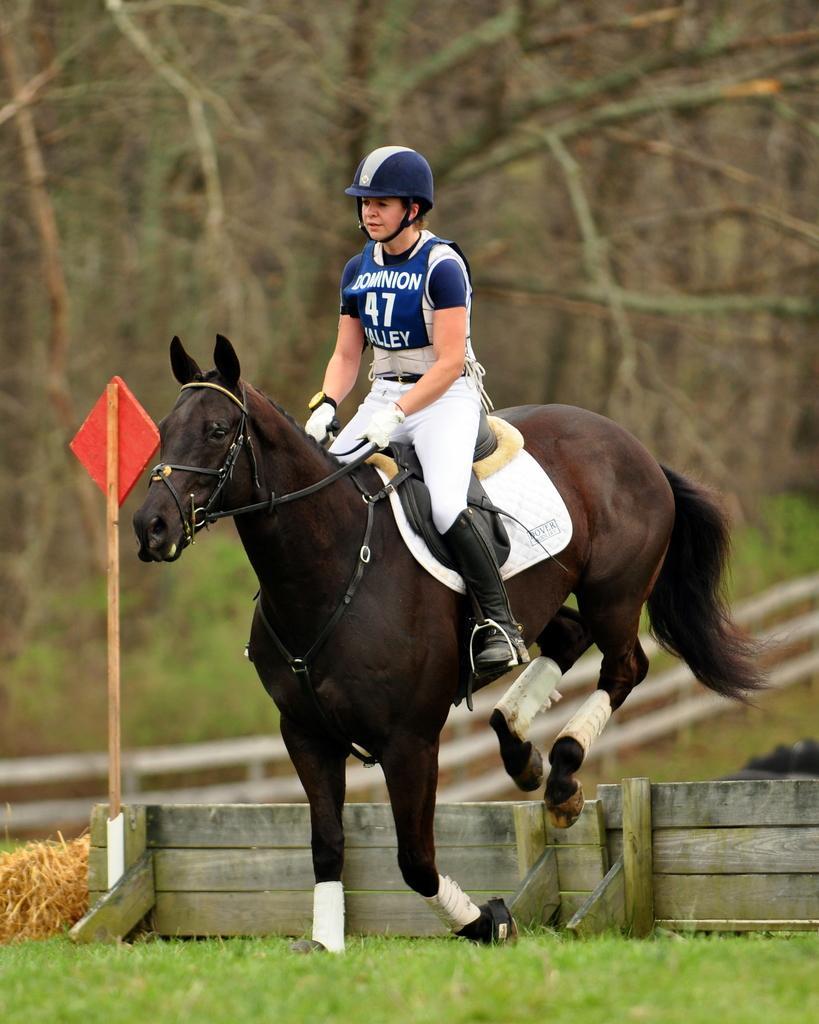In one or two sentences, can you explain what this image depicts? There is a black color horse. On the horse there is a saddle. And a person is sitting wearing helmet and gloves. There is a wooden wall. On that there is a pole with red color board. In the background there are trees. And in the ground there are grasses. 